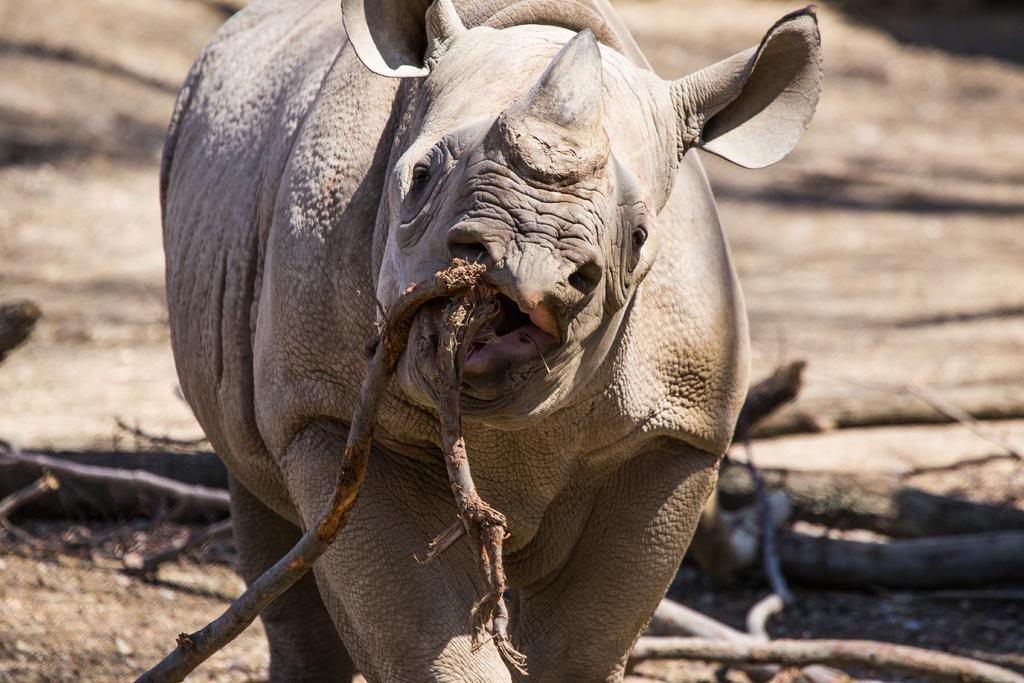What type of animal can be seen in the image? There is an animal in the image. How is the animal holding the wooden stick? The animal is holding a wooden stick with its mouth. What can be seen in the background of the image? There is land visible in the background of the image. What type of objects are present on the land in the background? There are wooden trunks on the land in the background. What type of cork can be seen floating in the water near the animal? There is no water or cork present in the image; it features an animal holding a wooden stick on land with wooden trunks in the background. 